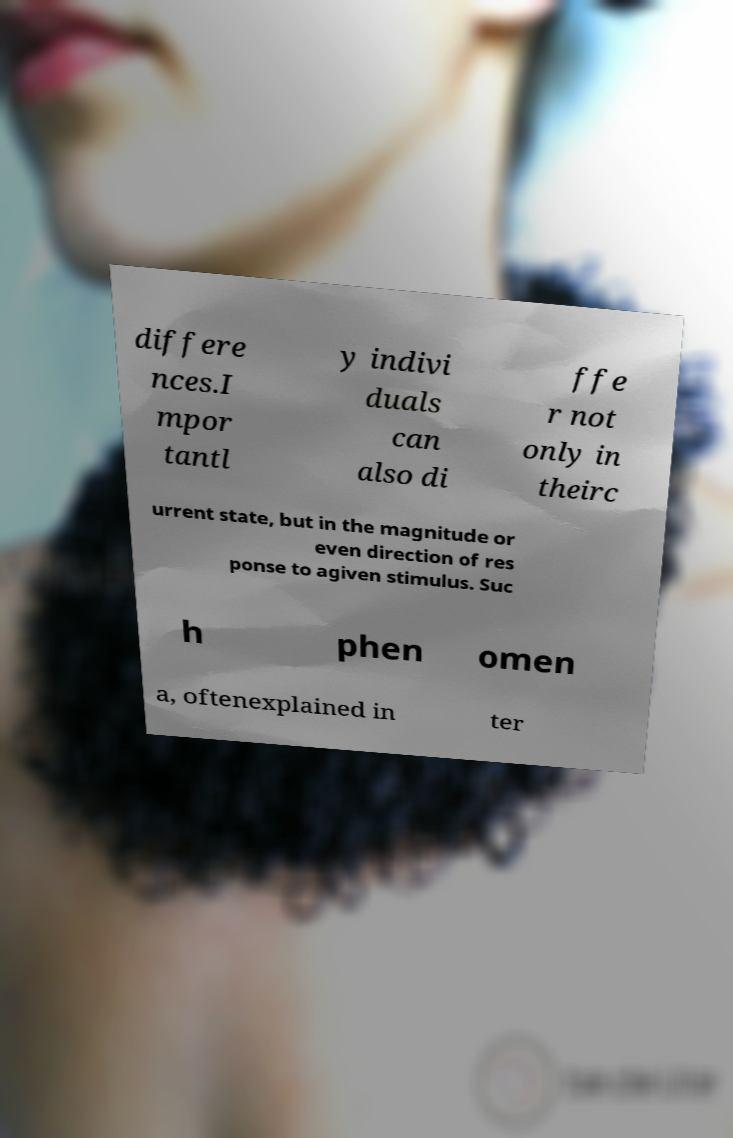I need the written content from this picture converted into text. Can you do that? differe nces.I mpor tantl y indivi duals can also di ffe r not only in theirc urrent state, but in the magnitude or even direction of res ponse to agiven stimulus. Suc h phen omen a, oftenexplained in ter 